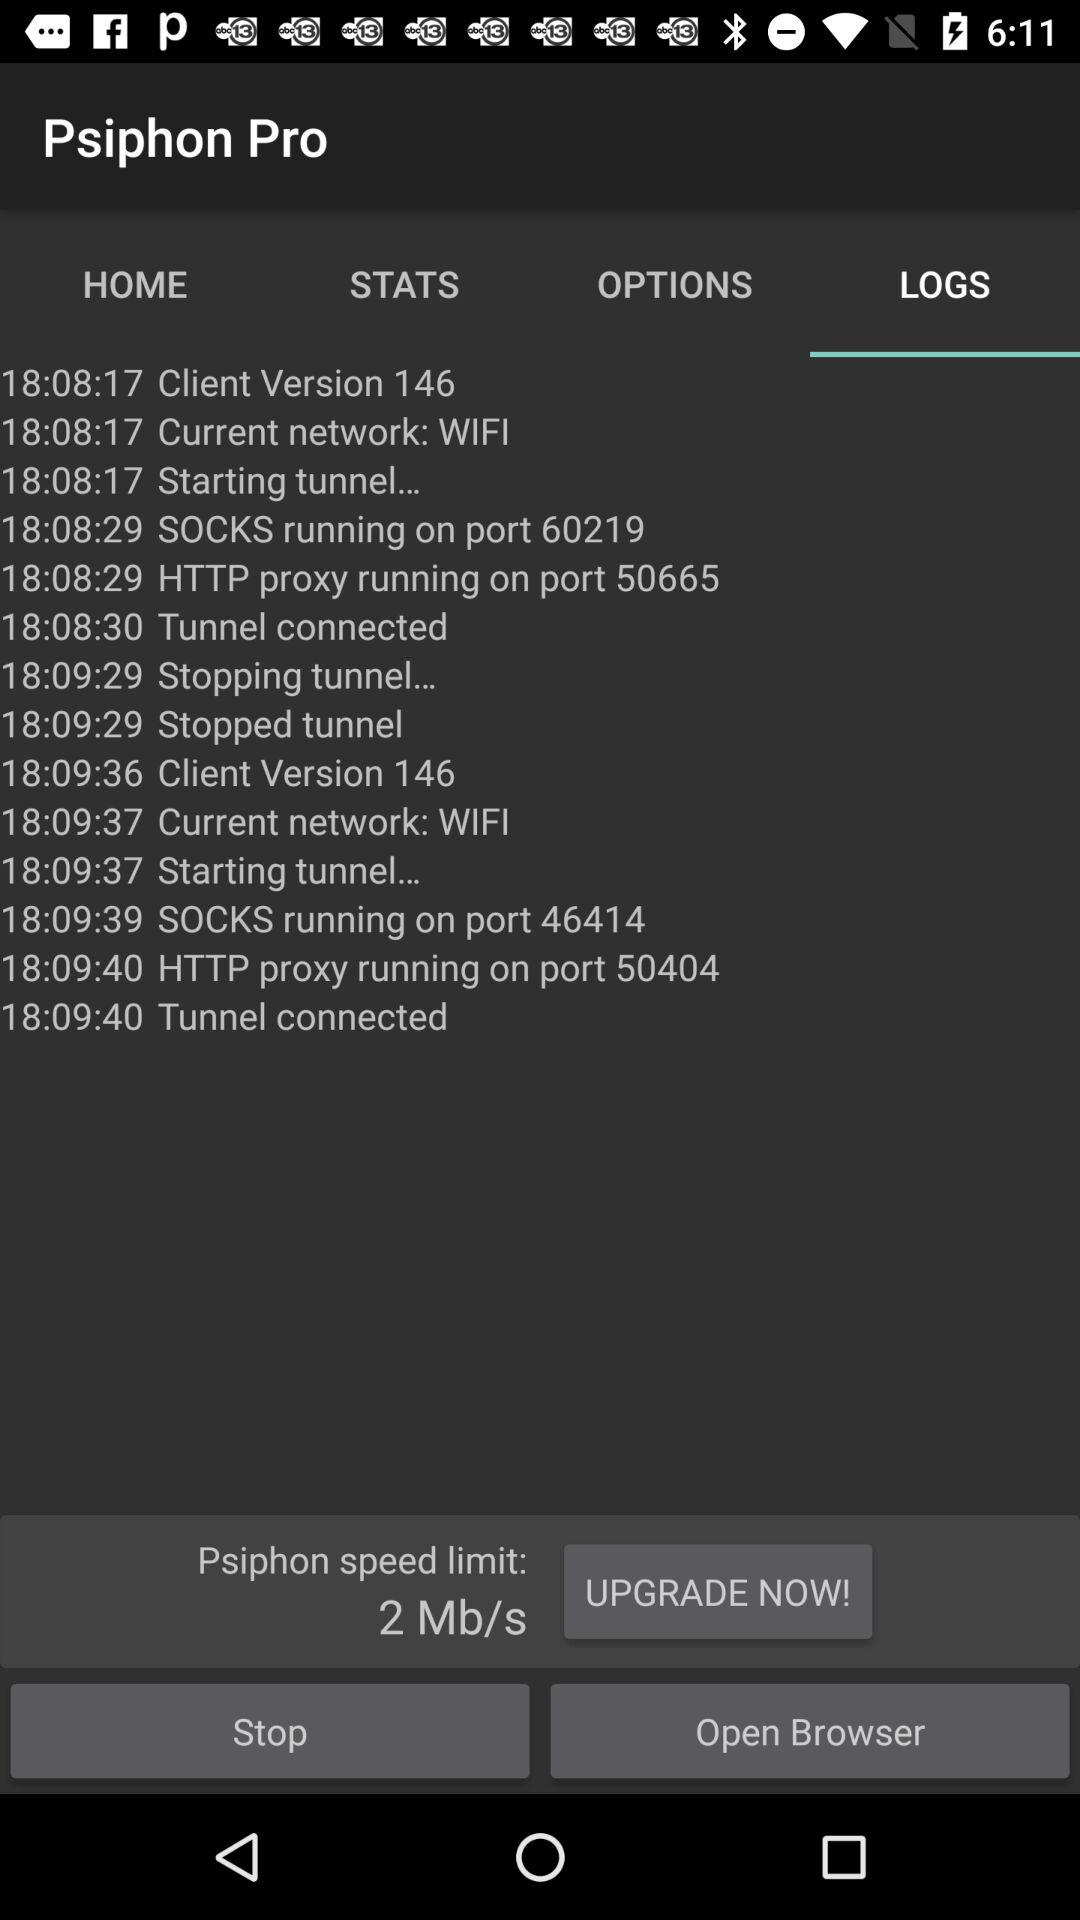What is the time for stopped tunnel? The time is 18:09:29. 